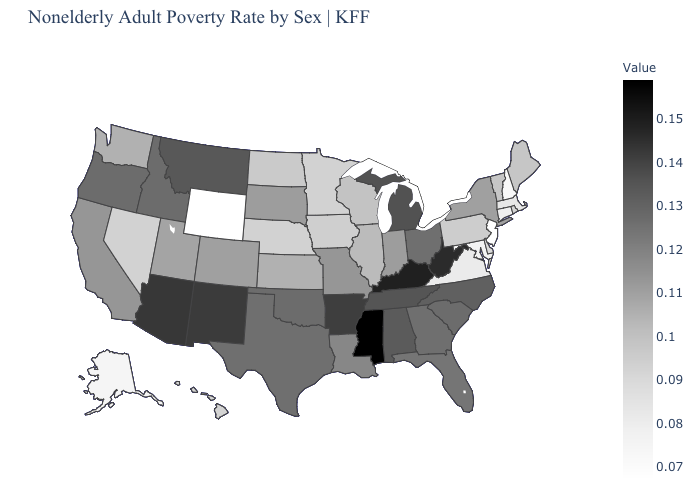Among the states that border Montana , which have the lowest value?
Quick response, please. Wyoming. Among the states that border Virginia , which have the highest value?
Answer briefly. Kentucky. Is the legend a continuous bar?
Concise answer only. Yes. 